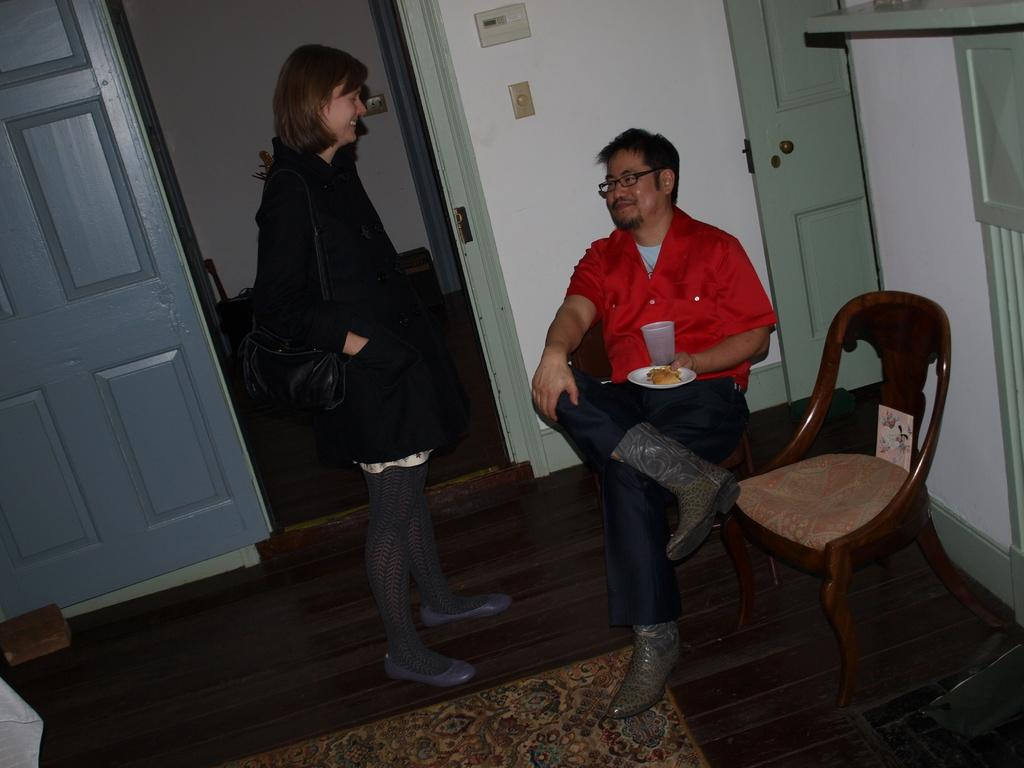How many people are in the image? There are two people in the image. What is the man doing in the image? The man is sitting in the image. What is the woman doing in the image? The woman is standing in the image. What type of experience does the tank provide for the people in the image? There is no tank present in the image, so it is not possible to determine what type of experience it might provide. 